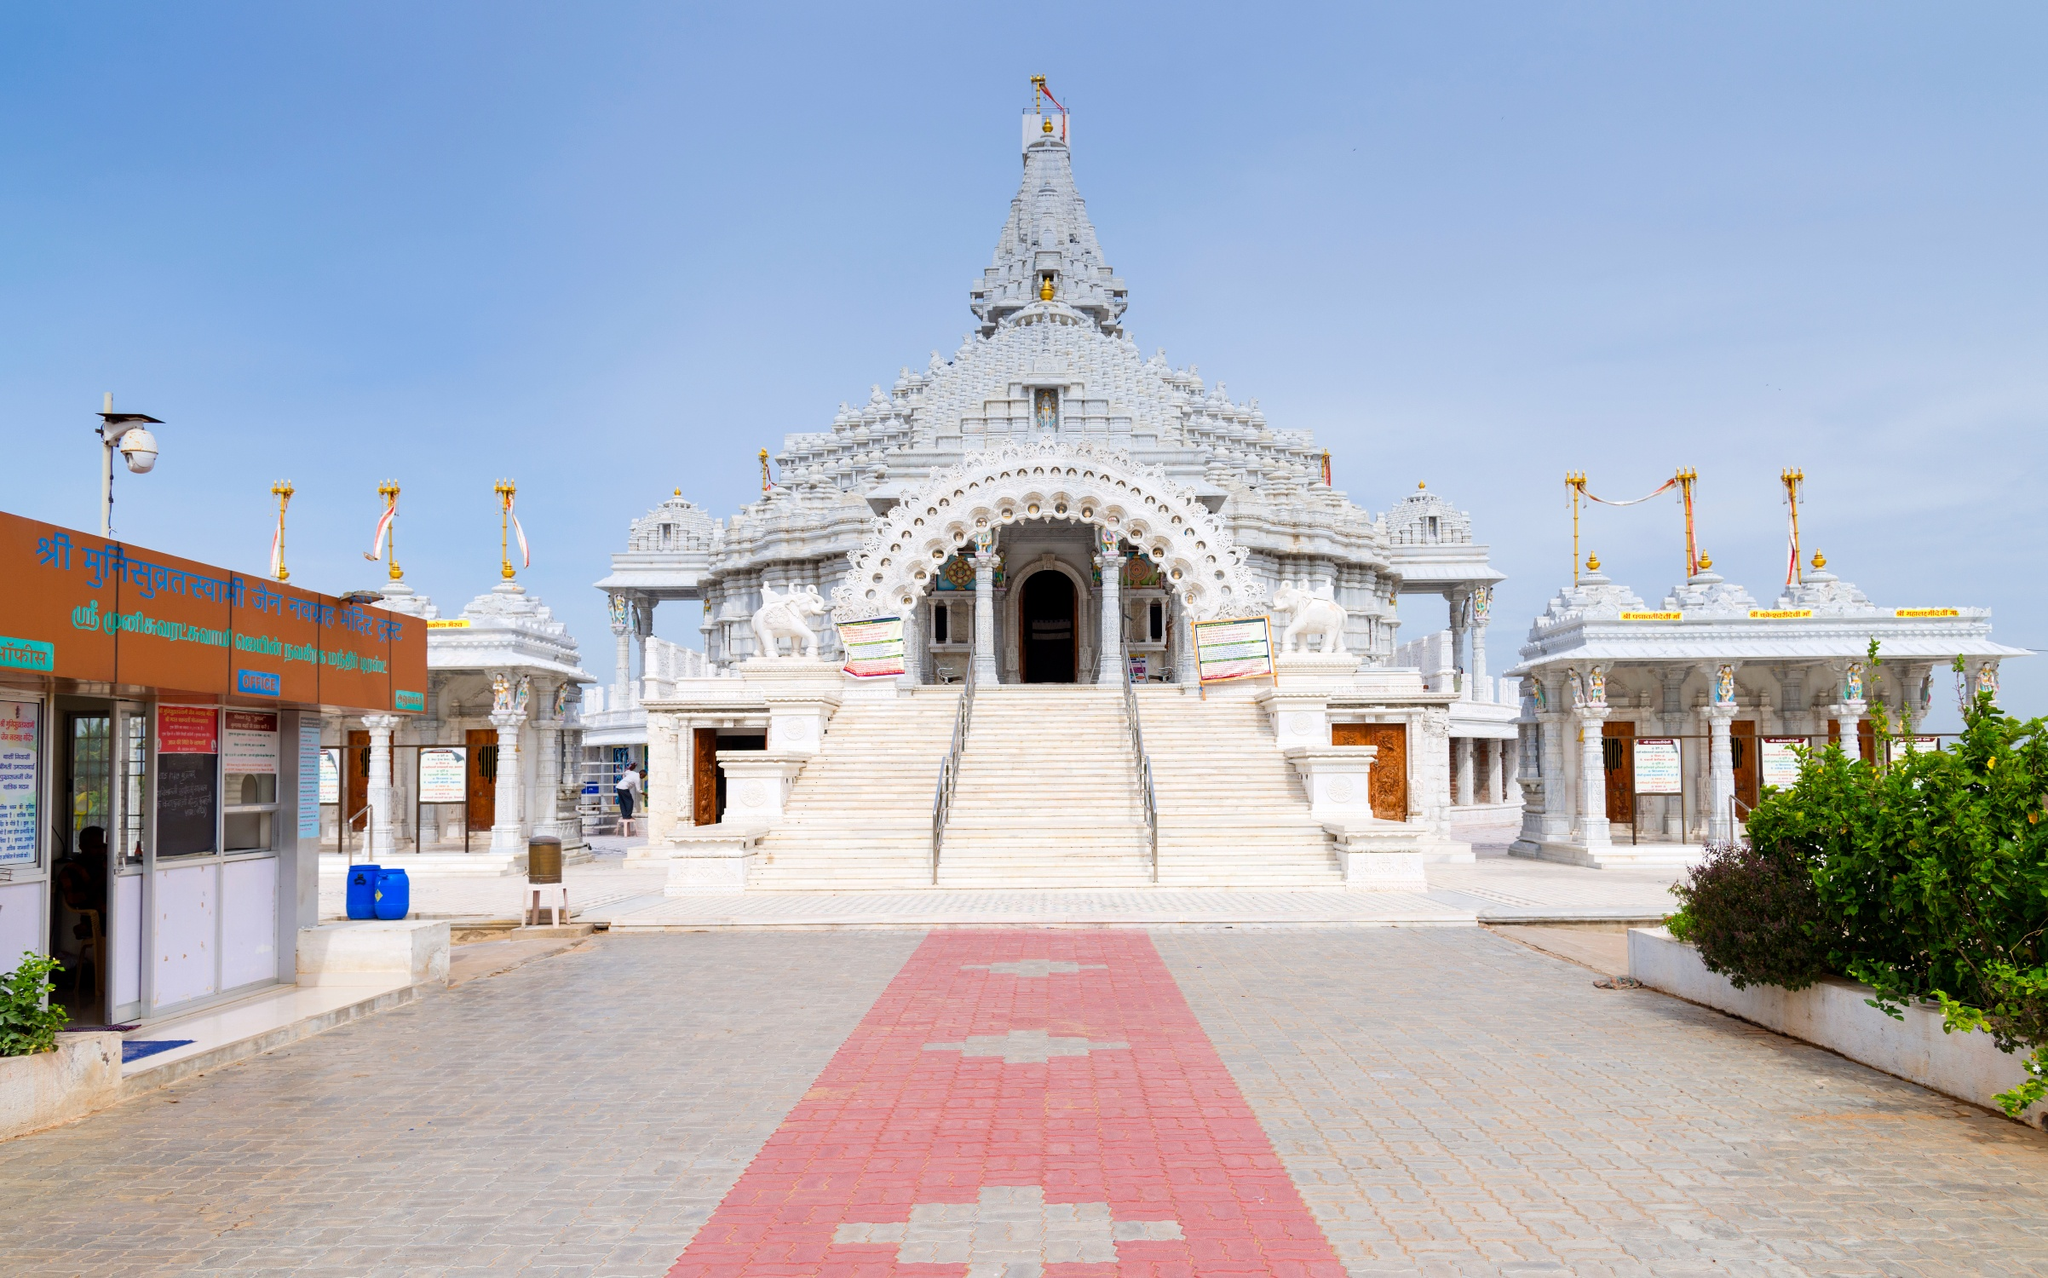Describe the following image. The image depicts a stunning Hindu temple constructed with pristine white marble, possibly signifying purity and serenity. It features intricate carvings and statues, which are common elements of traditional Hindu architecture, emblematic of the temple's cultural and religious significance. The central shikhara (spire), topped with what appears to be a flag, draws the eye upwards, signifying its reach towards the divine. The foreground of the image shows a pathway leading up to the temple, inviting visitors to enter this place of worship. Lush greenery partially frames the temple, indicating well-maintained grounds and adding to the peaceful ambience. 